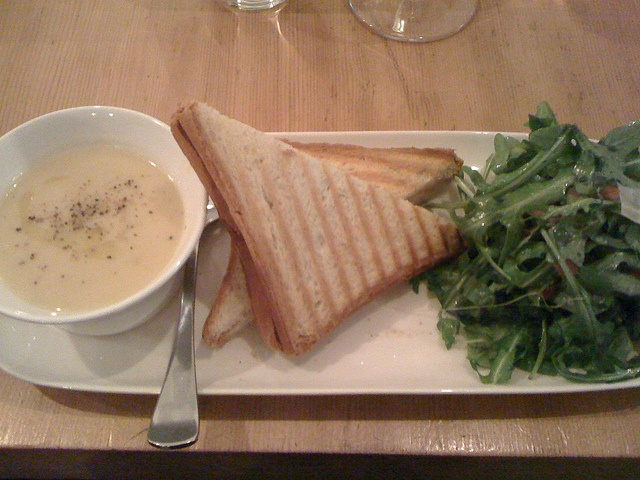Describe the objects in this image and their specific colors. I can see dining table in gray, tan, darkgray, and black tones, bowl in olive and tan tones, sandwich in olive, tan, and gray tones, sandwich in olive, gray, tan, and brown tones, and spoon in olive, gray, darkgray, and black tones in this image. 